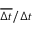<formula> <loc_0><loc_0><loc_500><loc_500>\overline { \Delta t } / \Delta t</formula> 